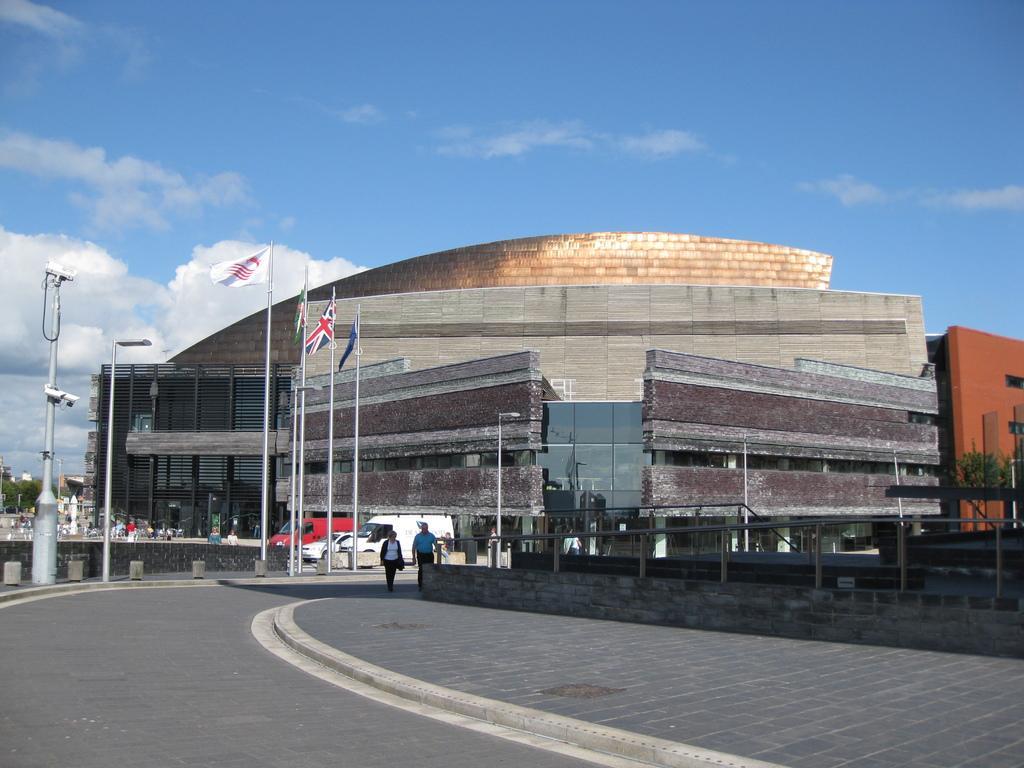In one or two sentences, can you explain what this image depicts? In this image we can see buildings, persons walking on the road, cc cameras, flags to the flag posts, street poles, street lights, trees and sky with clouds in the background. 